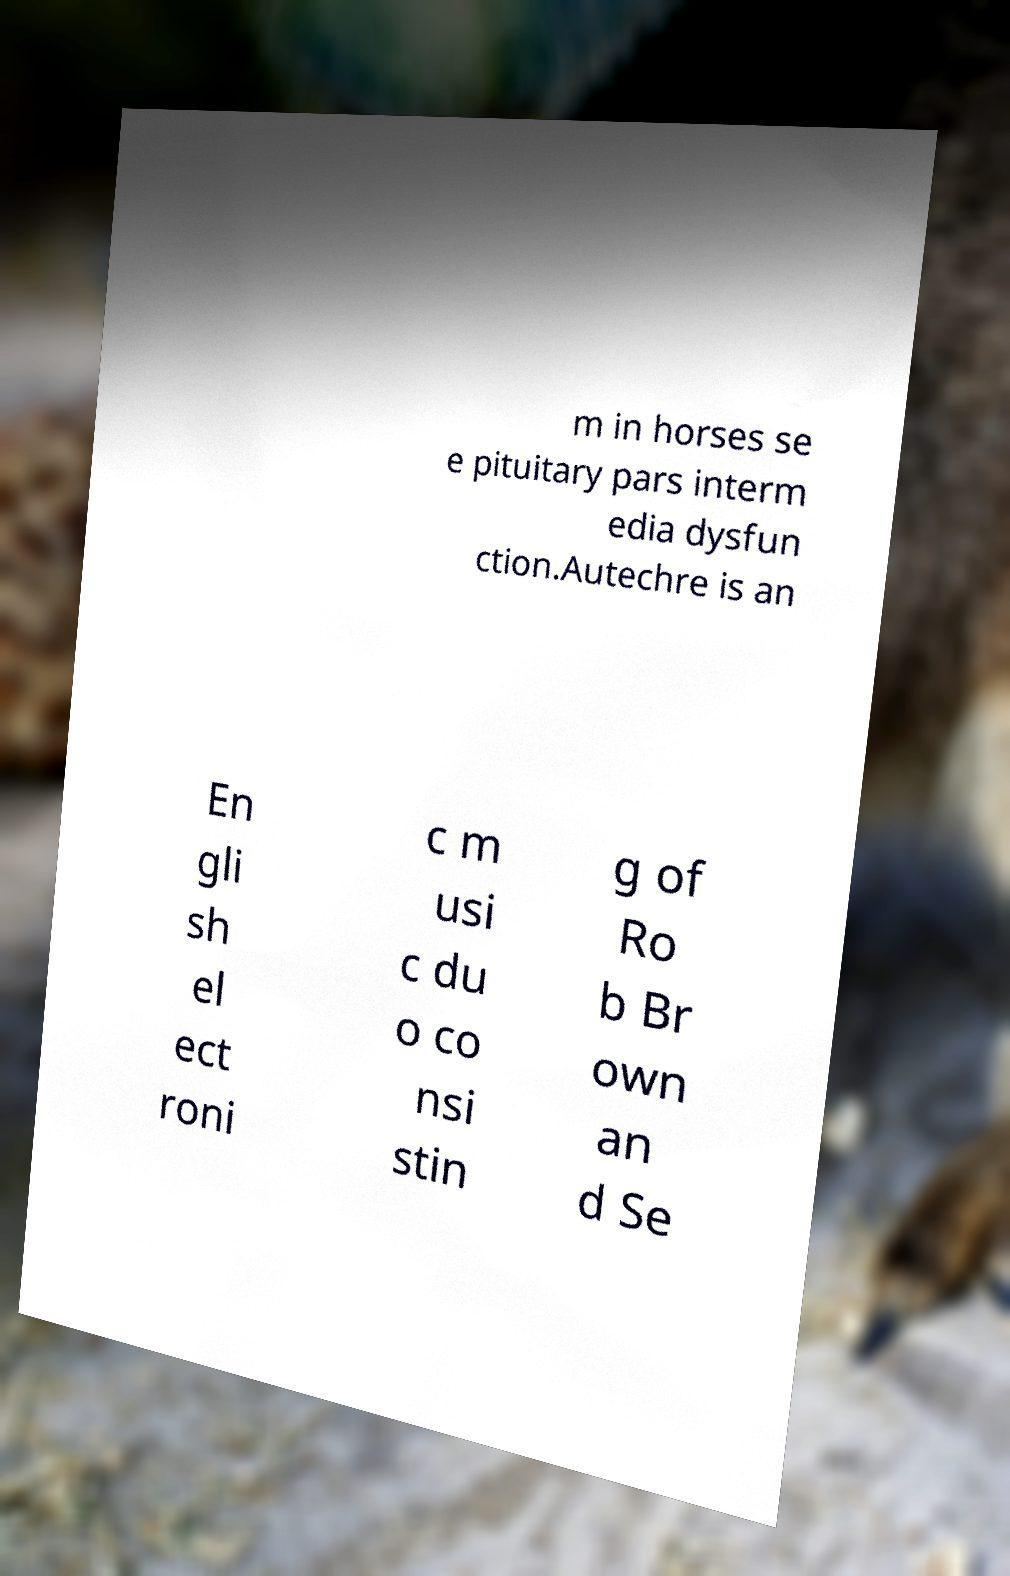Can you accurately transcribe the text from the provided image for me? m in horses se e pituitary pars interm edia dysfun ction.Autechre is an En gli sh el ect roni c m usi c du o co nsi stin g of Ro b Br own an d Se 